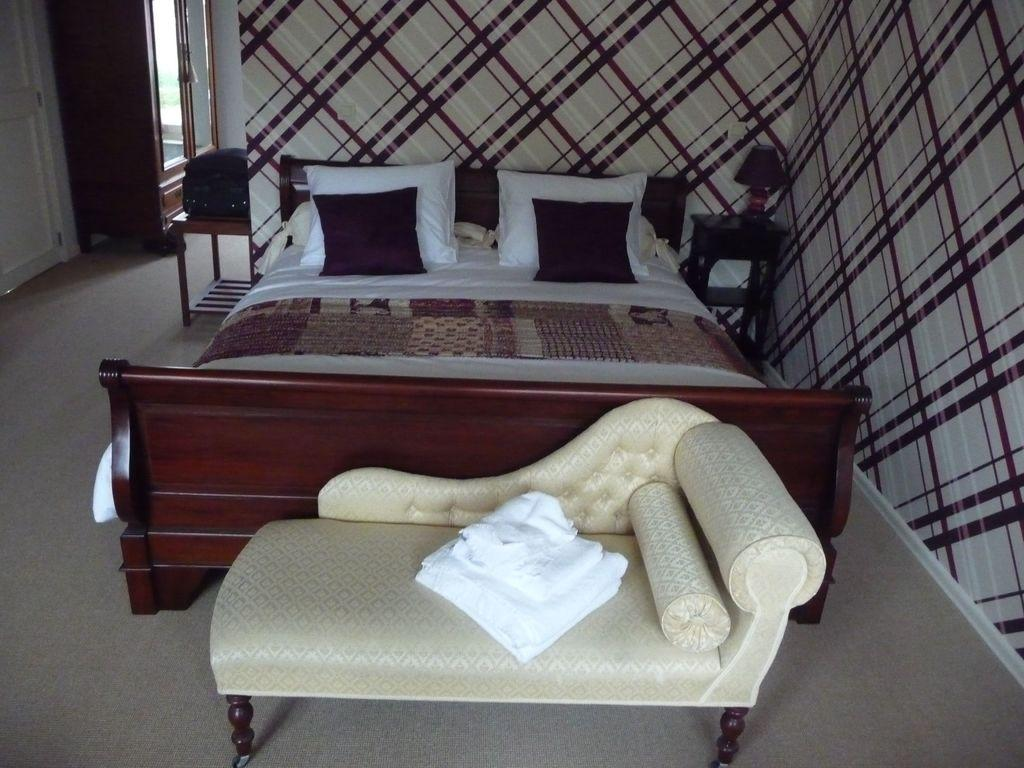What type of furniture is present in the image? There is a bed, pillows, a couch, a lamp, and a dressing table in the image. What can be seen on the bed? The bed has pillows on it. What type of lighting is present in the image? There is a lamp in the image. What is the purpose of the dressing table? The dressing table is likely used for personal grooming and makeup application. What is visible in the background of the image? There is a wall in the background of the image. How many girls are sitting at the table in the image? There is no table or girls present in the image. What type of heart-shaped object can be seen on the dressing table? There is no heart-shaped object visible on the dressing table in the image. 